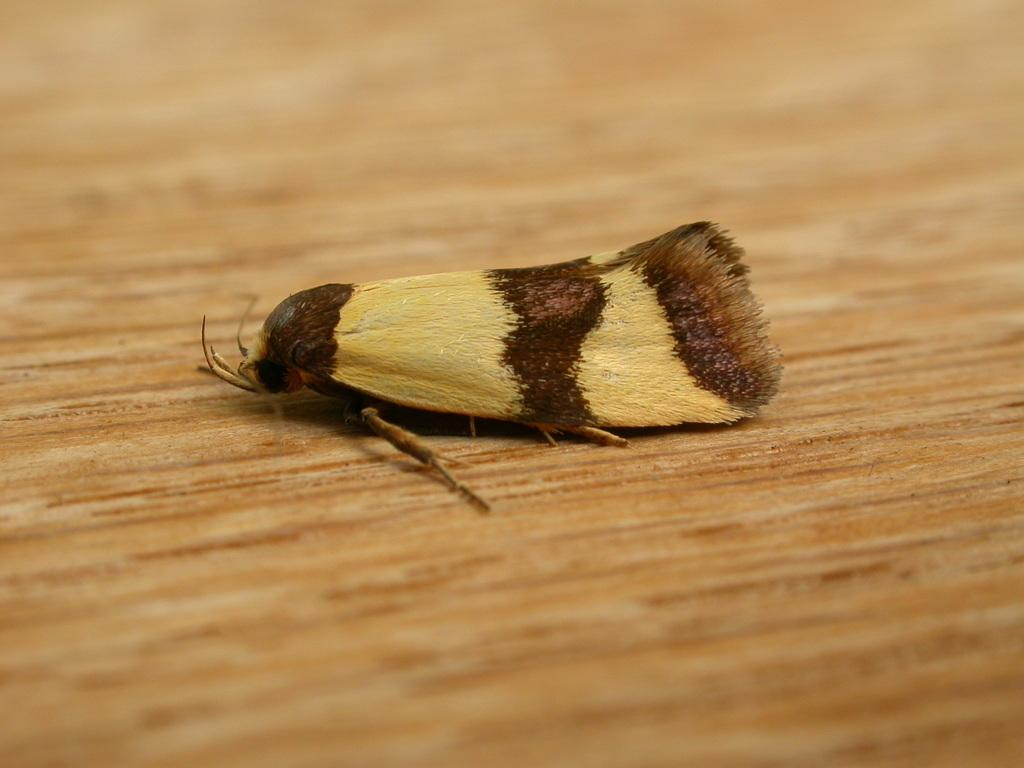What type of creature is in the image? There is an insect in the image. What colors can be seen on the insect? The insect has cream and brown colors. What is the insect resting on in the image? The insect is on a brown color surface. Can you tell me how many loaves of bread are in the image? There is no loaf of bread present in the image; it features an insect on a brown color surface. What type of request is being made in the image? There is no request being made in the image; it only shows an insect with cream and brown colors on a brown color surface. 